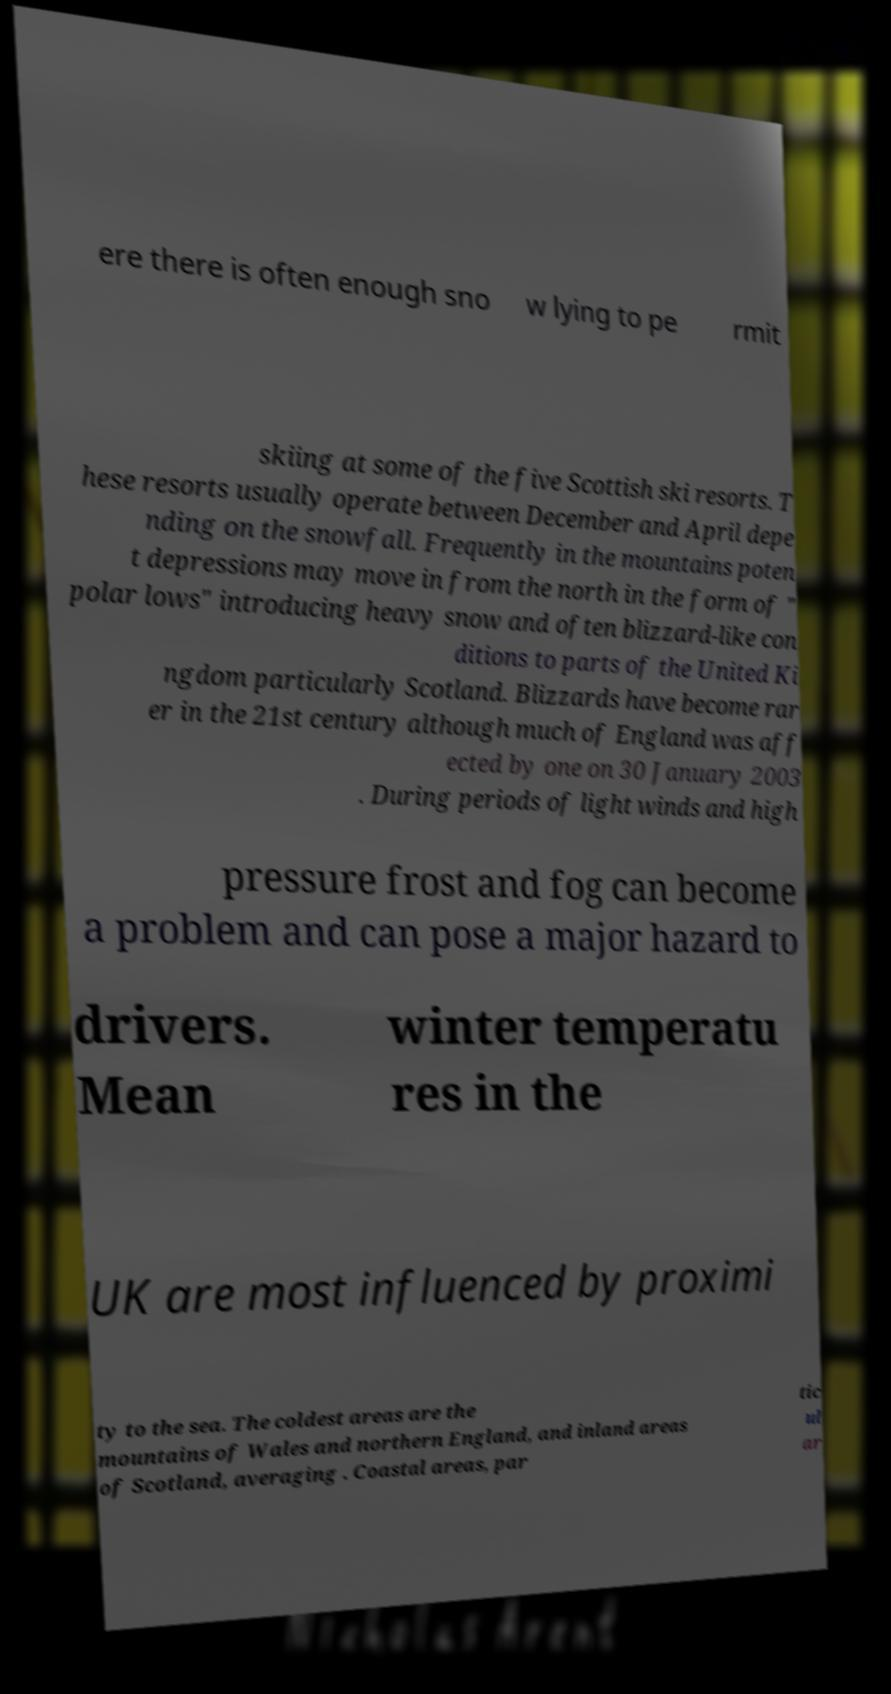For documentation purposes, I need the text within this image transcribed. Could you provide that? ere there is often enough sno w lying to pe rmit skiing at some of the five Scottish ski resorts. T hese resorts usually operate between December and April depe nding on the snowfall. Frequently in the mountains poten t depressions may move in from the north in the form of " polar lows" introducing heavy snow and often blizzard-like con ditions to parts of the United Ki ngdom particularly Scotland. Blizzards have become rar er in the 21st century although much of England was aff ected by one on 30 January 2003 . During periods of light winds and high pressure frost and fog can become a problem and can pose a major hazard to drivers. Mean winter temperatu res in the UK are most influenced by proximi ty to the sea. The coldest areas are the mountains of Wales and northern England, and inland areas of Scotland, averaging . Coastal areas, par tic ul ar 